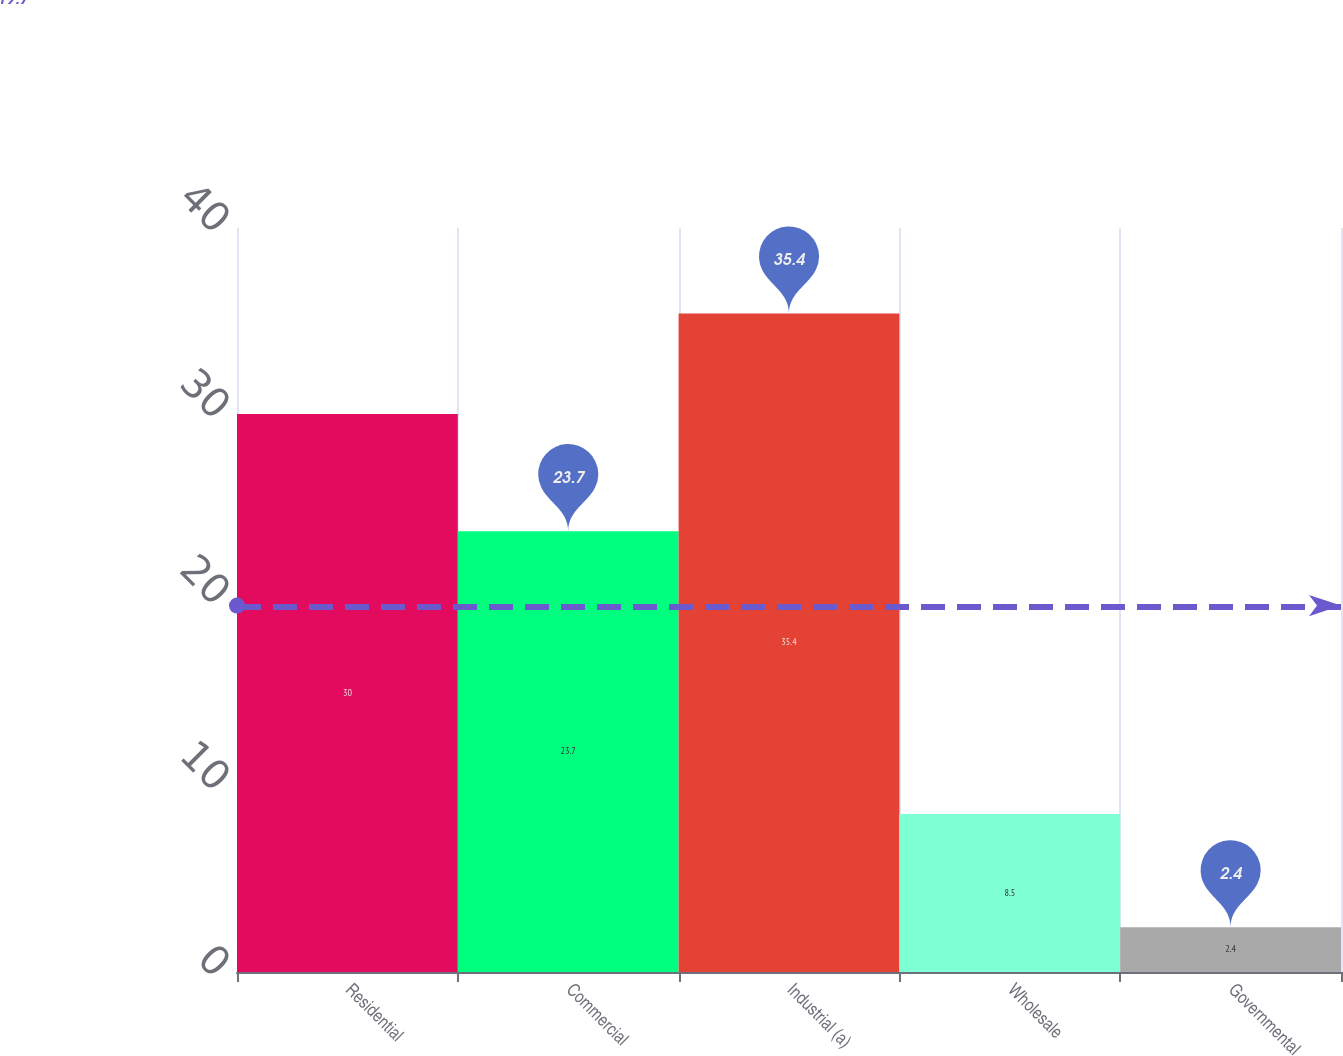Convert chart. <chart><loc_0><loc_0><loc_500><loc_500><bar_chart><fcel>Residential<fcel>Commercial<fcel>Industrial (a)<fcel>Wholesale<fcel>Governmental<nl><fcel>30<fcel>23.7<fcel>35.4<fcel>8.5<fcel>2.4<nl></chart> 